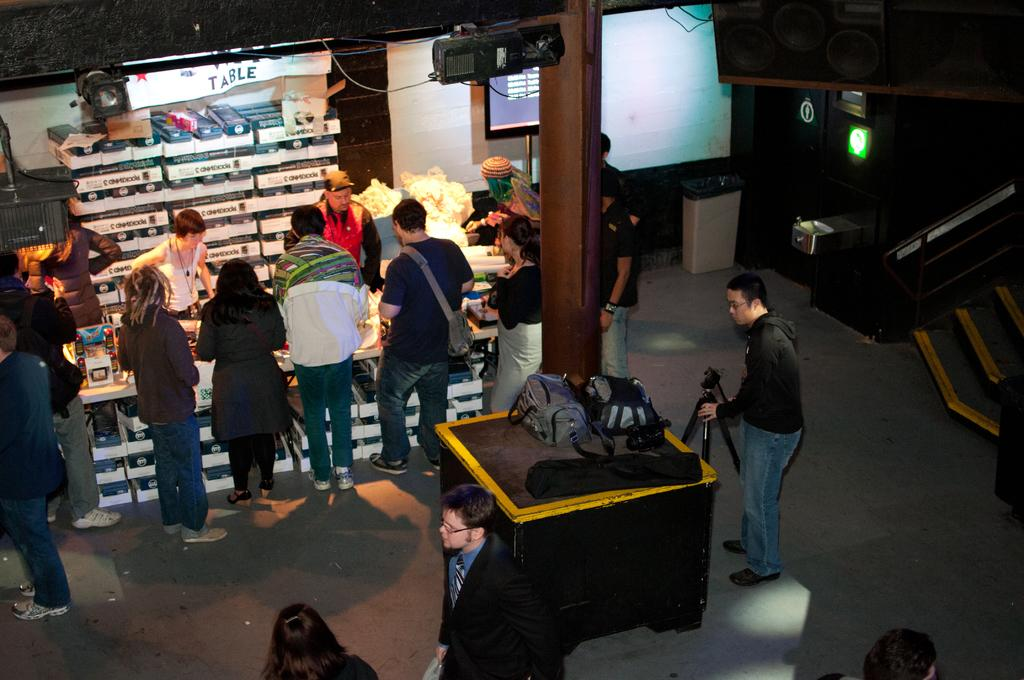What is the main subject of the image? The main subject of the image is a group of people standing. What object can be seen attached to a pole in the image? There is a television attached to a pole in the image. What is a person holding in the image? A person is holding a tripod stand in the image. How are the cardboard boxes arranged in the image? The cardboard boxes are arranged in an order in the image. What can be seen on a table in the image? Bags are present on a table in the image. What type of memory is stored in the cardboard boxes in the image? There is no indication of memory being stored in the cardboard boxes in the image; they are simply arranged in an order. How does the person holding the tripod stand stretch in the image? The person holding the tripod stand is not stretching in the image; they are simply holding the stand. 